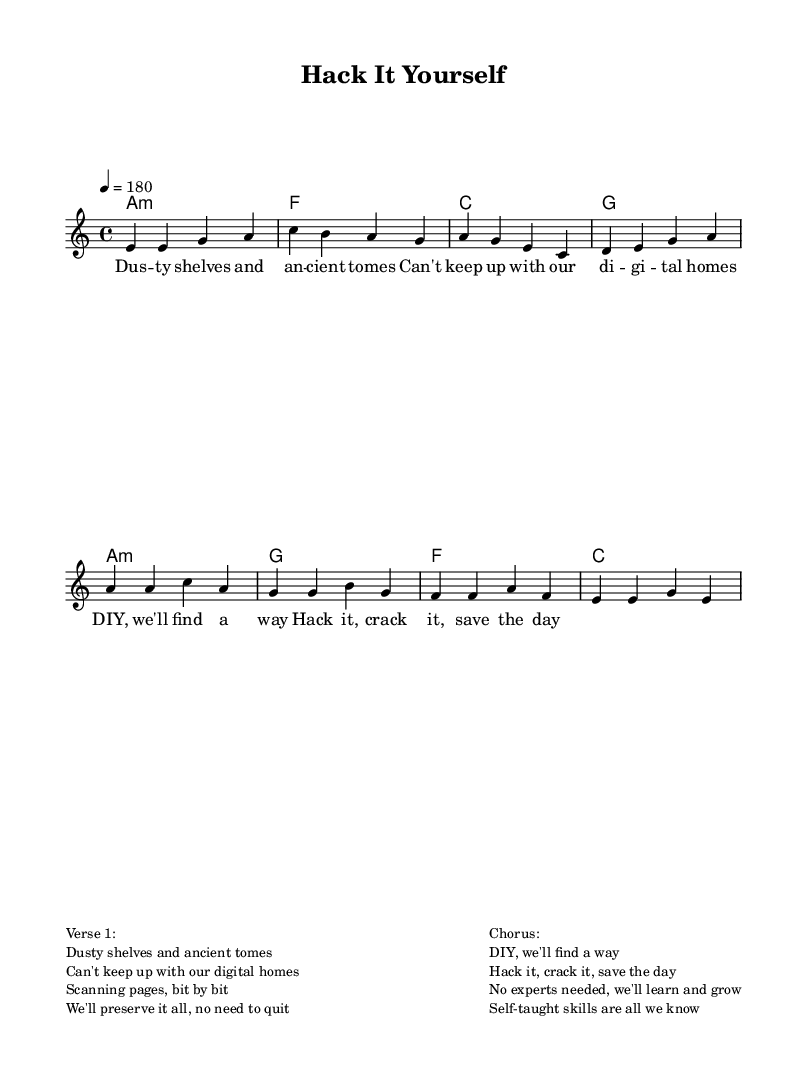What is the key signature of this music? The key signature is A minor, which has no sharps or flats.
Answer: A minor What is the time signature of this music? The time signature is indicated by the 4/4 symbol at the beginning of the score.
Answer: 4/4 What is the tempo marking for this song? The tempo marking is indicated as "4 = 180", meaning there are 180 beats per minute.
Answer: 180 How many verses are in the song? The song has one verse represented before the chorus, as shown in the structure.
Answer: One What chord is played in the first measure? The first measure contains an A minor chord indicated in the chord section.
Answer: A minor What theme does the song celebrate? The song celebrates self-taught tech skills and independent problem-solving, as reflected in the lyrics.
Answer: DIY tech skills What is the mood conveyed in the chorus? The chorus conveys a positive and assertive mood, emphasizing empowerment and self-reliance.
Answer: Empowering 